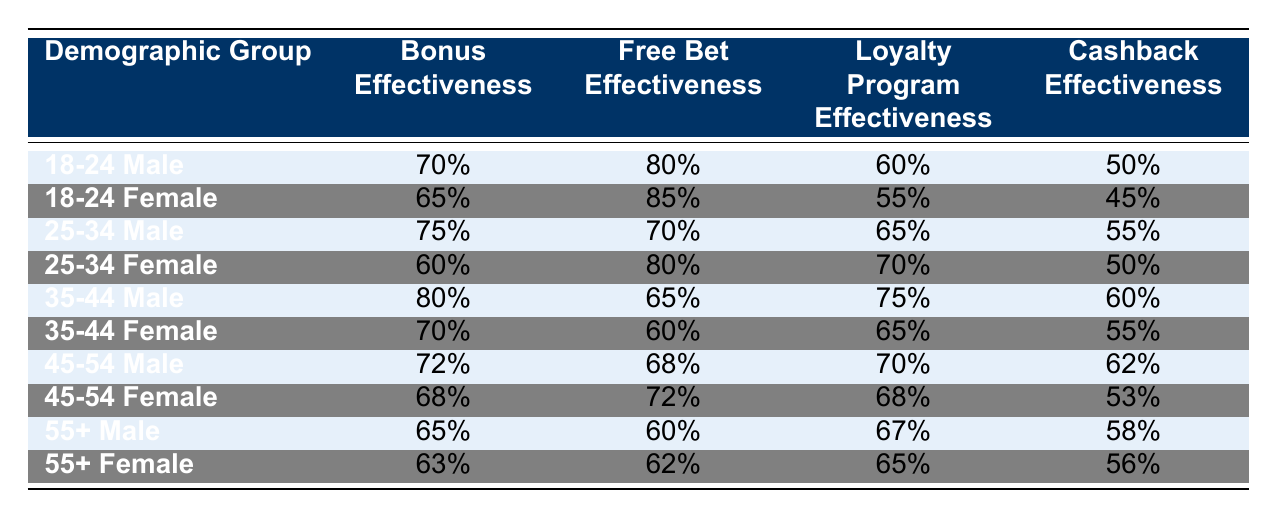What is the bonus effectiveness for the 35-44 Male demographic group? According to the table, the bonus effectiveness for the 35-44 Male demographic group is listed directly as 80%.
Answer: 80% Which demographic group has the highest free bet effectiveness? By comparing the free bet effectiveness values in the table, the 18-24 Female demographic group has the highest effectiveness at 85%.
Answer: 18-24 Female What is the average cashback effectiveness across all demographic groups? To find the average cashback effectiveness, we sum the cashback values (50 + 45 + 55 + 50 + 60 + 55 + 62 + 53 + 58 + 56 =  550) and divide by the number of groups (10), giving us an average of 550/10 = 55%.
Answer: 55% Is the loyalty program effectiveness for 25-34 Female higher than that of 45-54 Male? The loyalty program effectiveness for 25-34 Female is 70%, while for 45-54 Male it is 70%. Since both values are equal, the statement is false.
Answer: No Which demographic group has the greatest difference between bonus and free bet effectiveness? We calculate the difference between bonus and free bet effectiveness for each group: for 18-24 Male: 10%, 18-24 Female: 20%, 25-34 Male: -5%, 25-34 Female: 20%, 35-44 Male: 15%, 35-44 Female: 10%, 45-54 Male: 4%, 45-54 Female: 4%, 55+ Male: 5%, 55+ Female: 1%. The highest difference is 20%, which occurs in both 18-24 Female and 25-34 Female.
Answer: 20% What is the lower effectiveness value for cashback between 55+ Male and 55+ Female? Comparing the cashback effectiveness values, 55+ Male has 58% and 55+ Female has 56%. The lower value is for 55+ Female at 56%.
Answer: 56% 